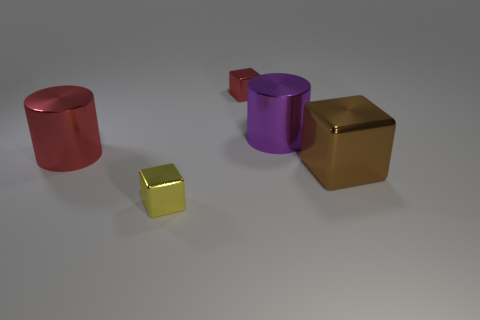What is the lighting source in this image? The image has a soft and diffused lighting, which suggests an omnidirectional light source. It's likely simulated as ambient light in the 3D environment, providing an even illumination to all objects without sharp shadows. 